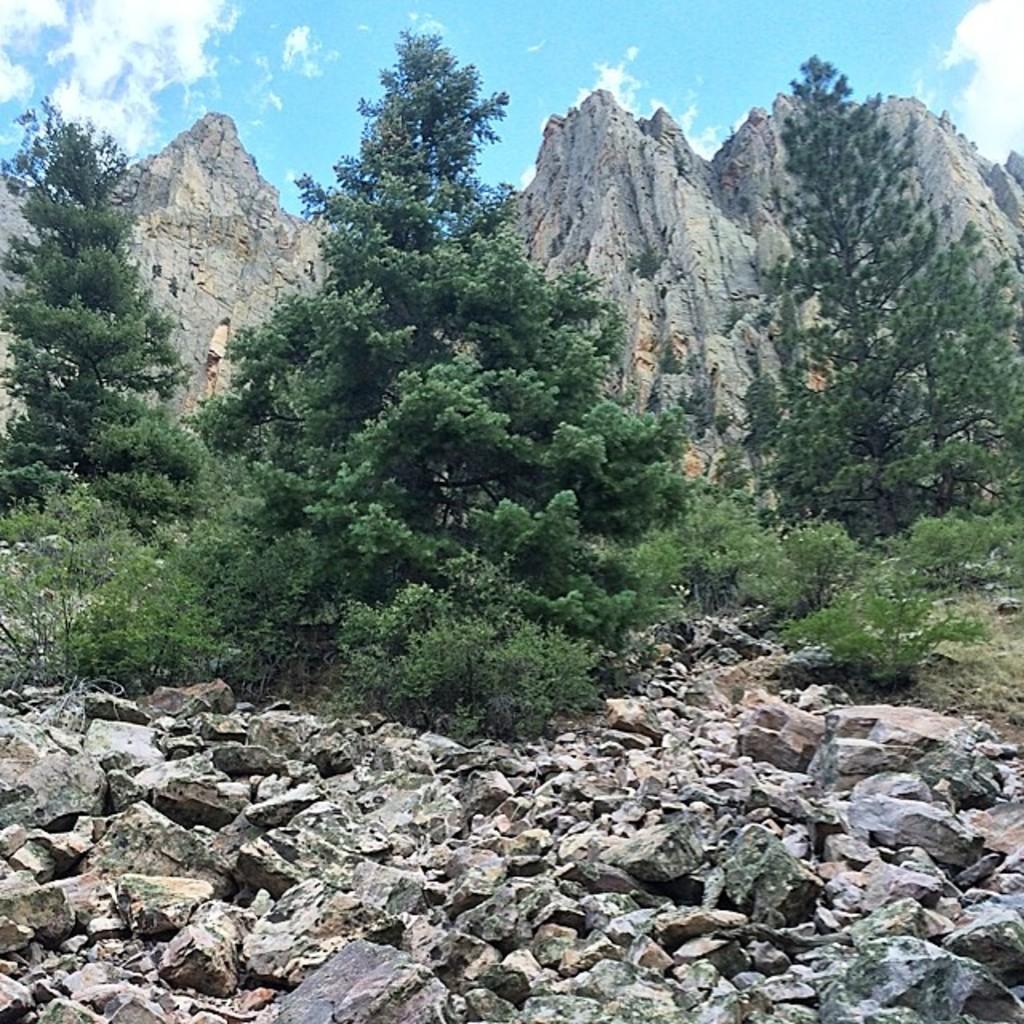Describe this image in one or two sentences. In this picture we can see few stones on the ground. There are few trees and mountains in the background. Sky is blue in color and cloudy. 